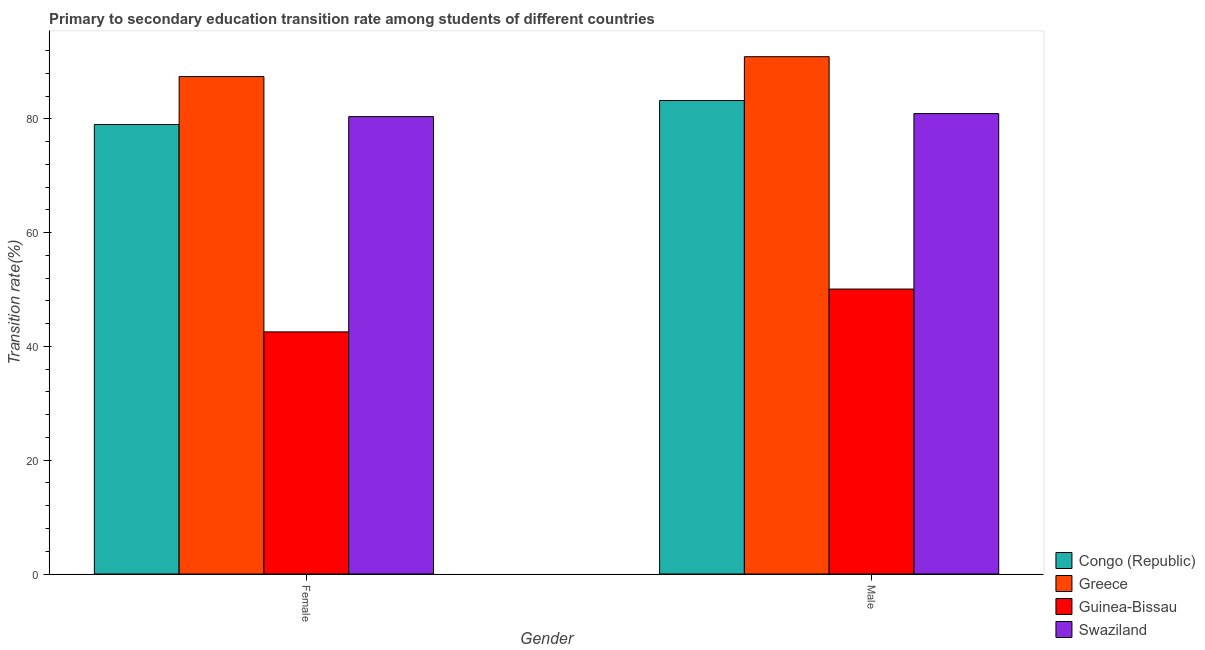How many groups of bars are there?
Give a very brief answer. 2. Are the number of bars on each tick of the X-axis equal?
Your response must be concise. Yes. How many bars are there on the 2nd tick from the right?
Provide a succinct answer. 4. What is the label of the 1st group of bars from the left?
Ensure brevity in your answer.  Female. What is the transition rate among male students in Guinea-Bissau?
Provide a succinct answer. 50.08. Across all countries, what is the maximum transition rate among male students?
Ensure brevity in your answer.  90.91. Across all countries, what is the minimum transition rate among male students?
Your answer should be very brief. 50.08. In which country was the transition rate among male students maximum?
Make the answer very short. Greece. In which country was the transition rate among female students minimum?
Your answer should be compact. Guinea-Bissau. What is the total transition rate among male students in the graph?
Offer a very short reply. 305.11. What is the difference between the transition rate among male students in Congo (Republic) and that in Guinea-Bissau?
Keep it short and to the point. 33.14. What is the difference between the transition rate among female students in Greece and the transition rate among male students in Congo (Republic)?
Provide a short and direct response. 4.21. What is the average transition rate among female students per country?
Your answer should be very brief. 72.33. What is the difference between the transition rate among female students and transition rate among male students in Swaziland?
Provide a succinct answer. -0.53. In how many countries, is the transition rate among male students greater than 60 %?
Your answer should be very brief. 3. What is the ratio of the transition rate among female students in Congo (Republic) to that in Greece?
Your answer should be compact. 0.9. Is the transition rate among male students in Congo (Republic) less than that in Swaziland?
Provide a short and direct response. No. In how many countries, is the transition rate among male students greater than the average transition rate among male students taken over all countries?
Provide a short and direct response. 3. What does the 4th bar from the right in Male represents?
Your response must be concise. Congo (Republic). How many bars are there?
Your answer should be compact. 8. Are all the bars in the graph horizontal?
Make the answer very short. No. Are the values on the major ticks of Y-axis written in scientific E-notation?
Provide a short and direct response. No. Does the graph contain any zero values?
Your answer should be very brief. No. Does the graph contain grids?
Your answer should be compact. No. Where does the legend appear in the graph?
Provide a short and direct response. Bottom right. How many legend labels are there?
Provide a short and direct response. 4. What is the title of the graph?
Make the answer very short. Primary to secondary education transition rate among students of different countries. What is the label or title of the Y-axis?
Ensure brevity in your answer.  Transition rate(%). What is the Transition rate(%) in Congo (Republic) in Female?
Offer a terse response. 78.99. What is the Transition rate(%) in Greece in Female?
Offer a terse response. 87.42. What is the Transition rate(%) of Guinea-Bissau in Female?
Offer a very short reply. 42.55. What is the Transition rate(%) of Swaziland in Female?
Your answer should be compact. 80.38. What is the Transition rate(%) in Congo (Republic) in Male?
Keep it short and to the point. 83.21. What is the Transition rate(%) of Greece in Male?
Offer a terse response. 90.91. What is the Transition rate(%) of Guinea-Bissau in Male?
Ensure brevity in your answer.  50.08. What is the Transition rate(%) in Swaziland in Male?
Keep it short and to the point. 80.91. Across all Gender, what is the maximum Transition rate(%) of Congo (Republic)?
Give a very brief answer. 83.21. Across all Gender, what is the maximum Transition rate(%) of Greece?
Provide a succinct answer. 90.91. Across all Gender, what is the maximum Transition rate(%) in Guinea-Bissau?
Offer a terse response. 50.08. Across all Gender, what is the maximum Transition rate(%) in Swaziland?
Provide a succinct answer. 80.91. Across all Gender, what is the minimum Transition rate(%) in Congo (Republic)?
Keep it short and to the point. 78.99. Across all Gender, what is the minimum Transition rate(%) in Greece?
Offer a very short reply. 87.42. Across all Gender, what is the minimum Transition rate(%) in Guinea-Bissau?
Keep it short and to the point. 42.55. Across all Gender, what is the minimum Transition rate(%) of Swaziland?
Provide a short and direct response. 80.38. What is the total Transition rate(%) in Congo (Republic) in the graph?
Give a very brief answer. 162.21. What is the total Transition rate(%) in Greece in the graph?
Your answer should be compact. 178.33. What is the total Transition rate(%) in Guinea-Bissau in the graph?
Keep it short and to the point. 92.63. What is the total Transition rate(%) of Swaziland in the graph?
Offer a very short reply. 161.28. What is the difference between the Transition rate(%) in Congo (Republic) in Female and that in Male?
Offer a terse response. -4.22. What is the difference between the Transition rate(%) of Greece in Female and that in Male?
Ensure brevity in your answer.  -3.49. What is the difference between the Transition rate(%) of Guinea-Bissau in Female and that in Male?
Keep it short and to the point. -7.53. What is the difference between the Transition rate(%) of Swaziland in Female and that in Male?
Give a very brief answer. -0.53. What is the difference between the Transition rate(%) of Congo (Republic) in Female and the Transition rate(%) of Greece in Male?
Make the answer very short. -11.92. What is the difference between the Transition rate(%) in Congo (Republic) in Female and the Transition rate(%) in Guinea-Bissau in Male?
Offer a very short reply. 28.92. What is the difference between the Transition rate(%) in Congo (Republic) in Female and the Transition rate(%) in Swaziland in Male?
Ensure brevity in your answer.  -1.91. What is the difference between the Transition rate(%) in Greece in Female and the Transition rate(%) in Guinea-Bissau in Male?
Keep it short and to the point. 37.34. What is the difference between the Transition rate(%) in Greece in Female and the Transition rate(%) in Swaziland in Male?
Provide a succinct answer. 6.51. What is the difference between the Transition rate(%) of Guinea-Bissau in Female and the Transition rate(%) of Swaziland in Male?
Make the answer very short. -38.36. What is the average Transition rate(%) in Congo (Republic) per Gender?
Ensure brevity in your answer.  81.1. What is the average Transition rate(%) of Greece per Gender?
Make the answer very short. 89.16. What is the average Transition rate(%) of Guinea-Bissau per Gender?
Give a very brief answer. 46.31. What is the average Transition rate(%) in Swaziland per Gender?
Ensure brevity in your answer.  80.64. What is the difference between the Transition rate(%) of Congo (Republic) and Transition rate(%) of Greece in Female?
Provide a short and direct response. -8.42. What is the difference between the Transition rate(%) in Congo (Republic) and Transition rate(%) in Guinea-Bissau in Female?
Make the answer very short. 36.44. What is the difference between the Transition rate(%) in Congo (Republic) and Transition rate(%) in Swaziland in Female?
Provide a succinct answer. -1.38. What is the difference between the Transition rate(%) in Greece and Transition rate(%) in Guinea-Bissau in Female?
Keep it short and to the point. 44.87. What is the difference between the Transition rate(%) in Greece and Transition rate(%) in Swaziland in Female?
Your response must be concise. 7.04. What is the difference between the Transition rate(%) in Guinea-Bissau and Transition rate(%) in Swaziland in Female?
Offer a terse response. -37.83. What is the difference between the Transition rate(%) in Congo (Republic) and Transition rate(%) in Greece in Male?
Keep it short and to the point. -7.7. What is the difference between the Transition rate(%) of Congo (Republic) and Transition rate(%) of Guinea-Bissau in Male?
Provide a short and direct response. 33.14. What is the difference between the Transition rate(%) of Congo (Republic) and Transition rate(%) of Swaziland in Male?
Provide a short and direct response. 2.3. What is the difference between the Transition rate(%) in Greece and Transition rate(%) in Guinea-Bissau in Male?
Your answer should be very brief. 40.83. What is the difference between the Transition rate(%) in Greece and Transition rate(%) in Swaziland in Male?
Provide a short and direct response. 10. What is the difference between the Transition rate(%) of Guinea-Bissau and Transition rate(%) of Swaziland in Male?
Provide a succinct answer. -30.83. What is the ratio of the Transition rate(%) in Congo (Republic) in Female to that in Male?
Your answer should be compact. 0.95. What is the ratio of the Transition rate(%) of Greece in Female to that in Male?
Ensure brevity in your answer.  0.96. What is the ratio of the Transition rate(%) of Guinea-Bissau in Female to that in Male?
Keep it short and to the point. 0.85. What is the difference between the highest and the second highest Transition rate(%) of Congo (Republic)?
Give a very brief answer. 4.22. What is the difference between the highest and the second highest Transition rate(%) of Greece?
Offer a very short reply. 3.49. What is the difference between the highest and the second highest Transition rate(%) of Guinea-Bissau?
Provide a short and direct response. 7.53. What is the difference between the highest and the second highest Transition rate(%) of Swaziland?
Your answer should be very brief. 0.53. What is the difference between the highest and the lowest Transition rate(%) in Congo (Republic)?
Make the answer very short. 4.22. What is the difference between the highest and the lowest Transition rate(%) of Greece?
Your response must be concise. 3.49. What is the difference between the highest and the lowest Transition rate(%) of Guinea-Bissau?
Provide a short and direct response. 7.53. What is the difference between the highest and the lowest Transition rate(%) of Swaziland?
Keep it short and to the point. 0.53. 